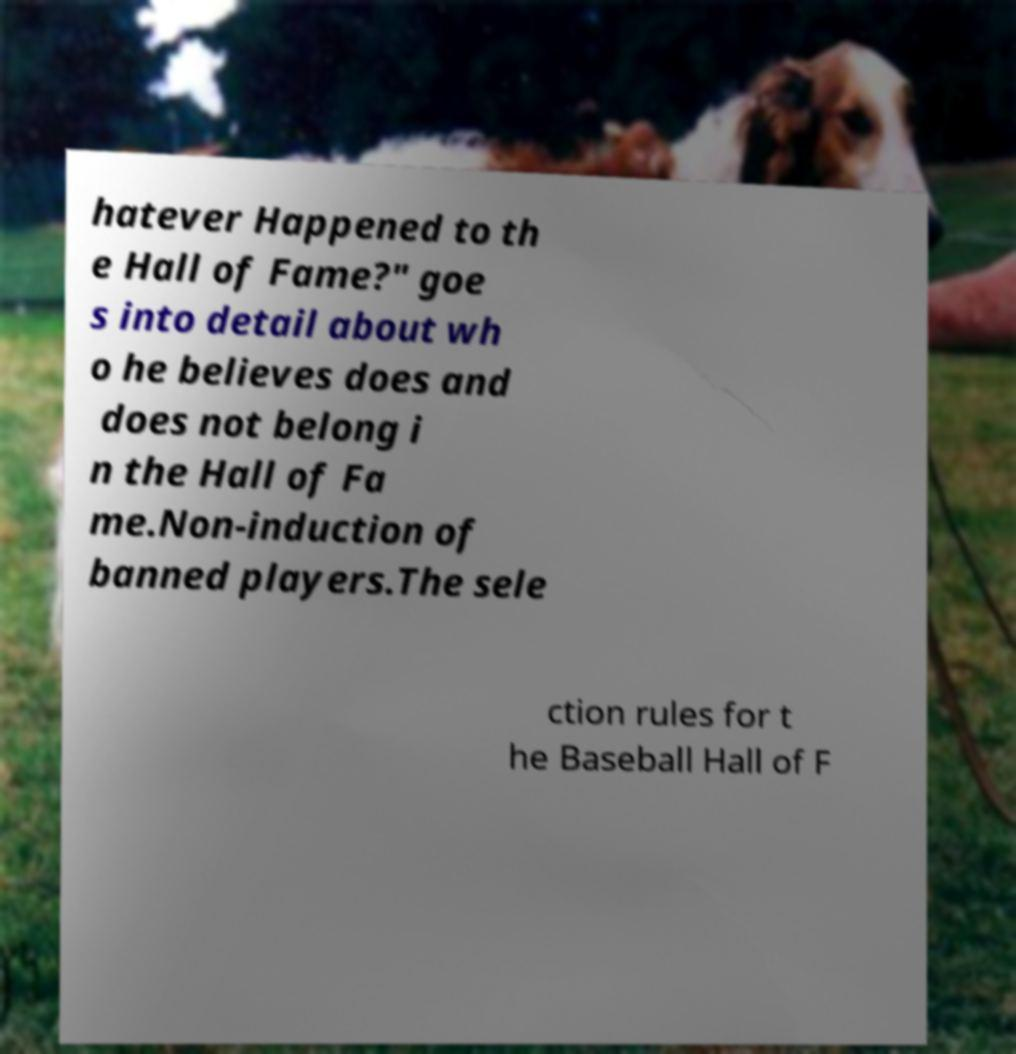Please identify and transcribe the text found in this image. hatever Happened to th e Hall of Fame?" goe s into detail about wh o he believes does and does not belong i n the Hall of Fa me.Non-induction of banned players.The sele ction rules for t he Baseball Hall of F 